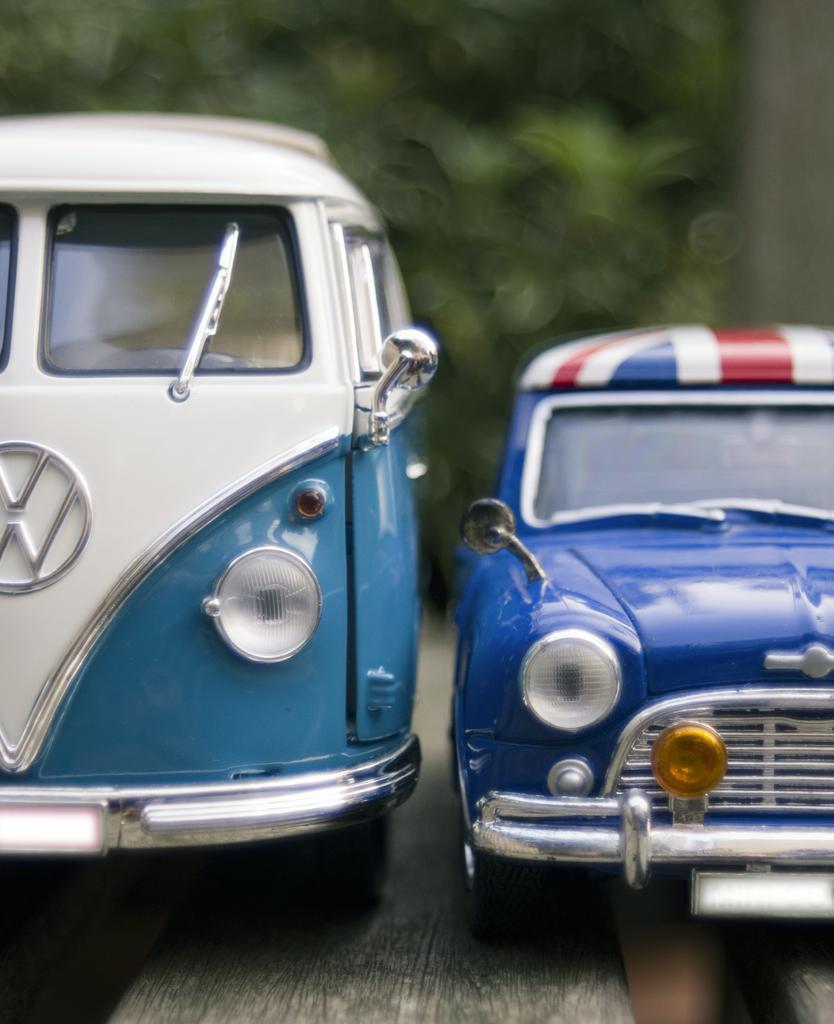Can you describe this image briefly? In the picture I can see a blue color car on the right side of the image and a van on the left side of the image. Here we can see the wooden surface. The background of the image is blurred, which is in green color. 